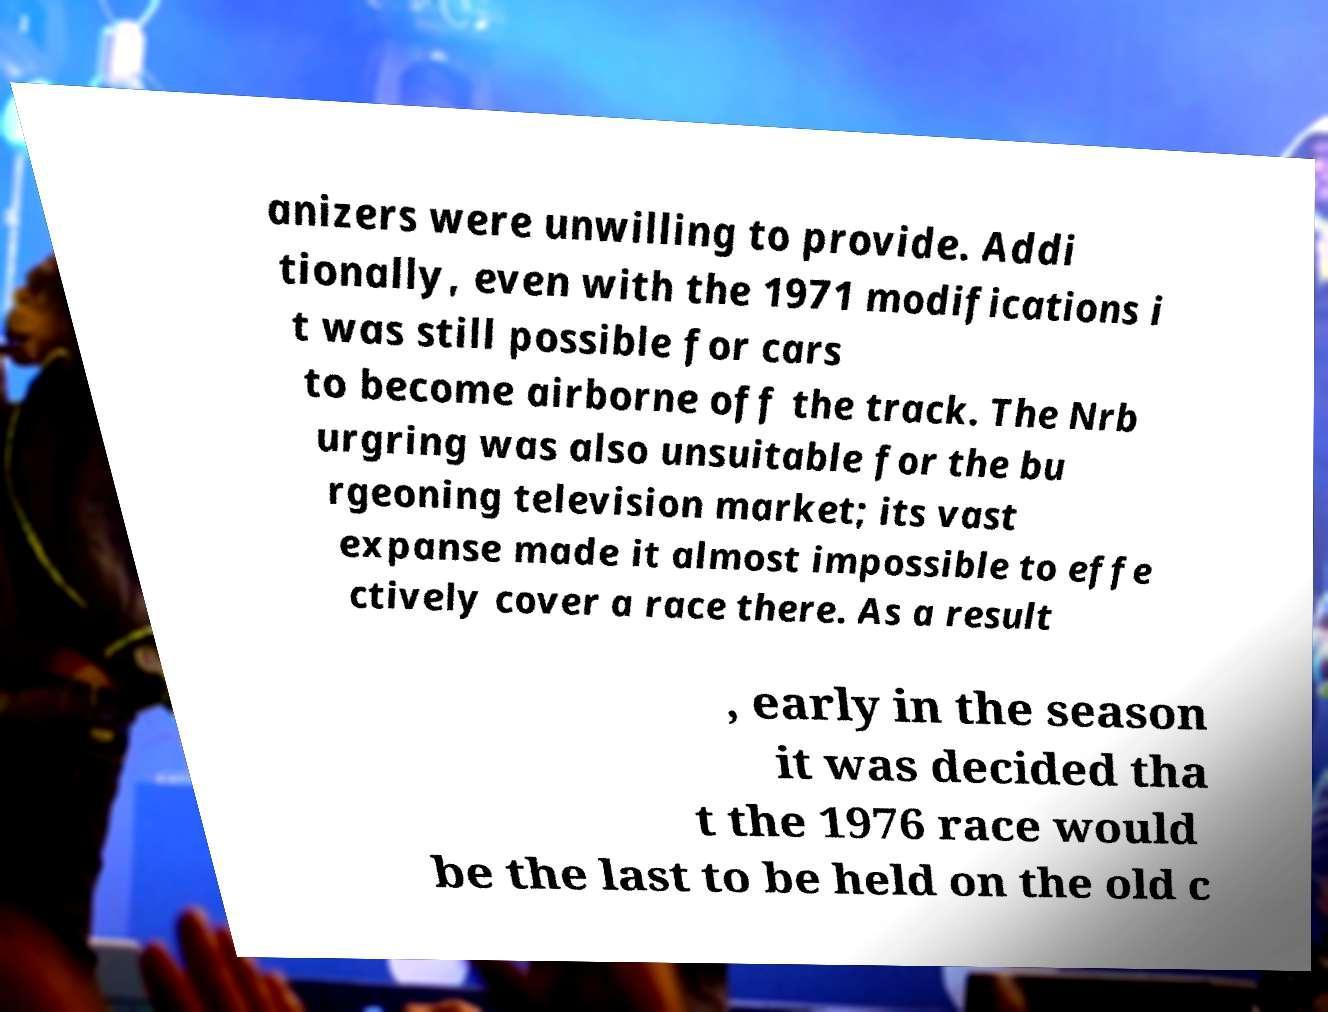Please read and relay the text visible in this image. What does it say? anizers were unwilling to provide. Addi tionally, even with the 1971 modifications i t was still possible for cars to become airborne off the track. The Nrb urgring was also unsuitable for the bu rgeoning television market; its vast expanse made it almost impossible to effe ctively cover a race there. As a result , early in the season it was decided tha t the 1976 race would be the last to be held on the old c 